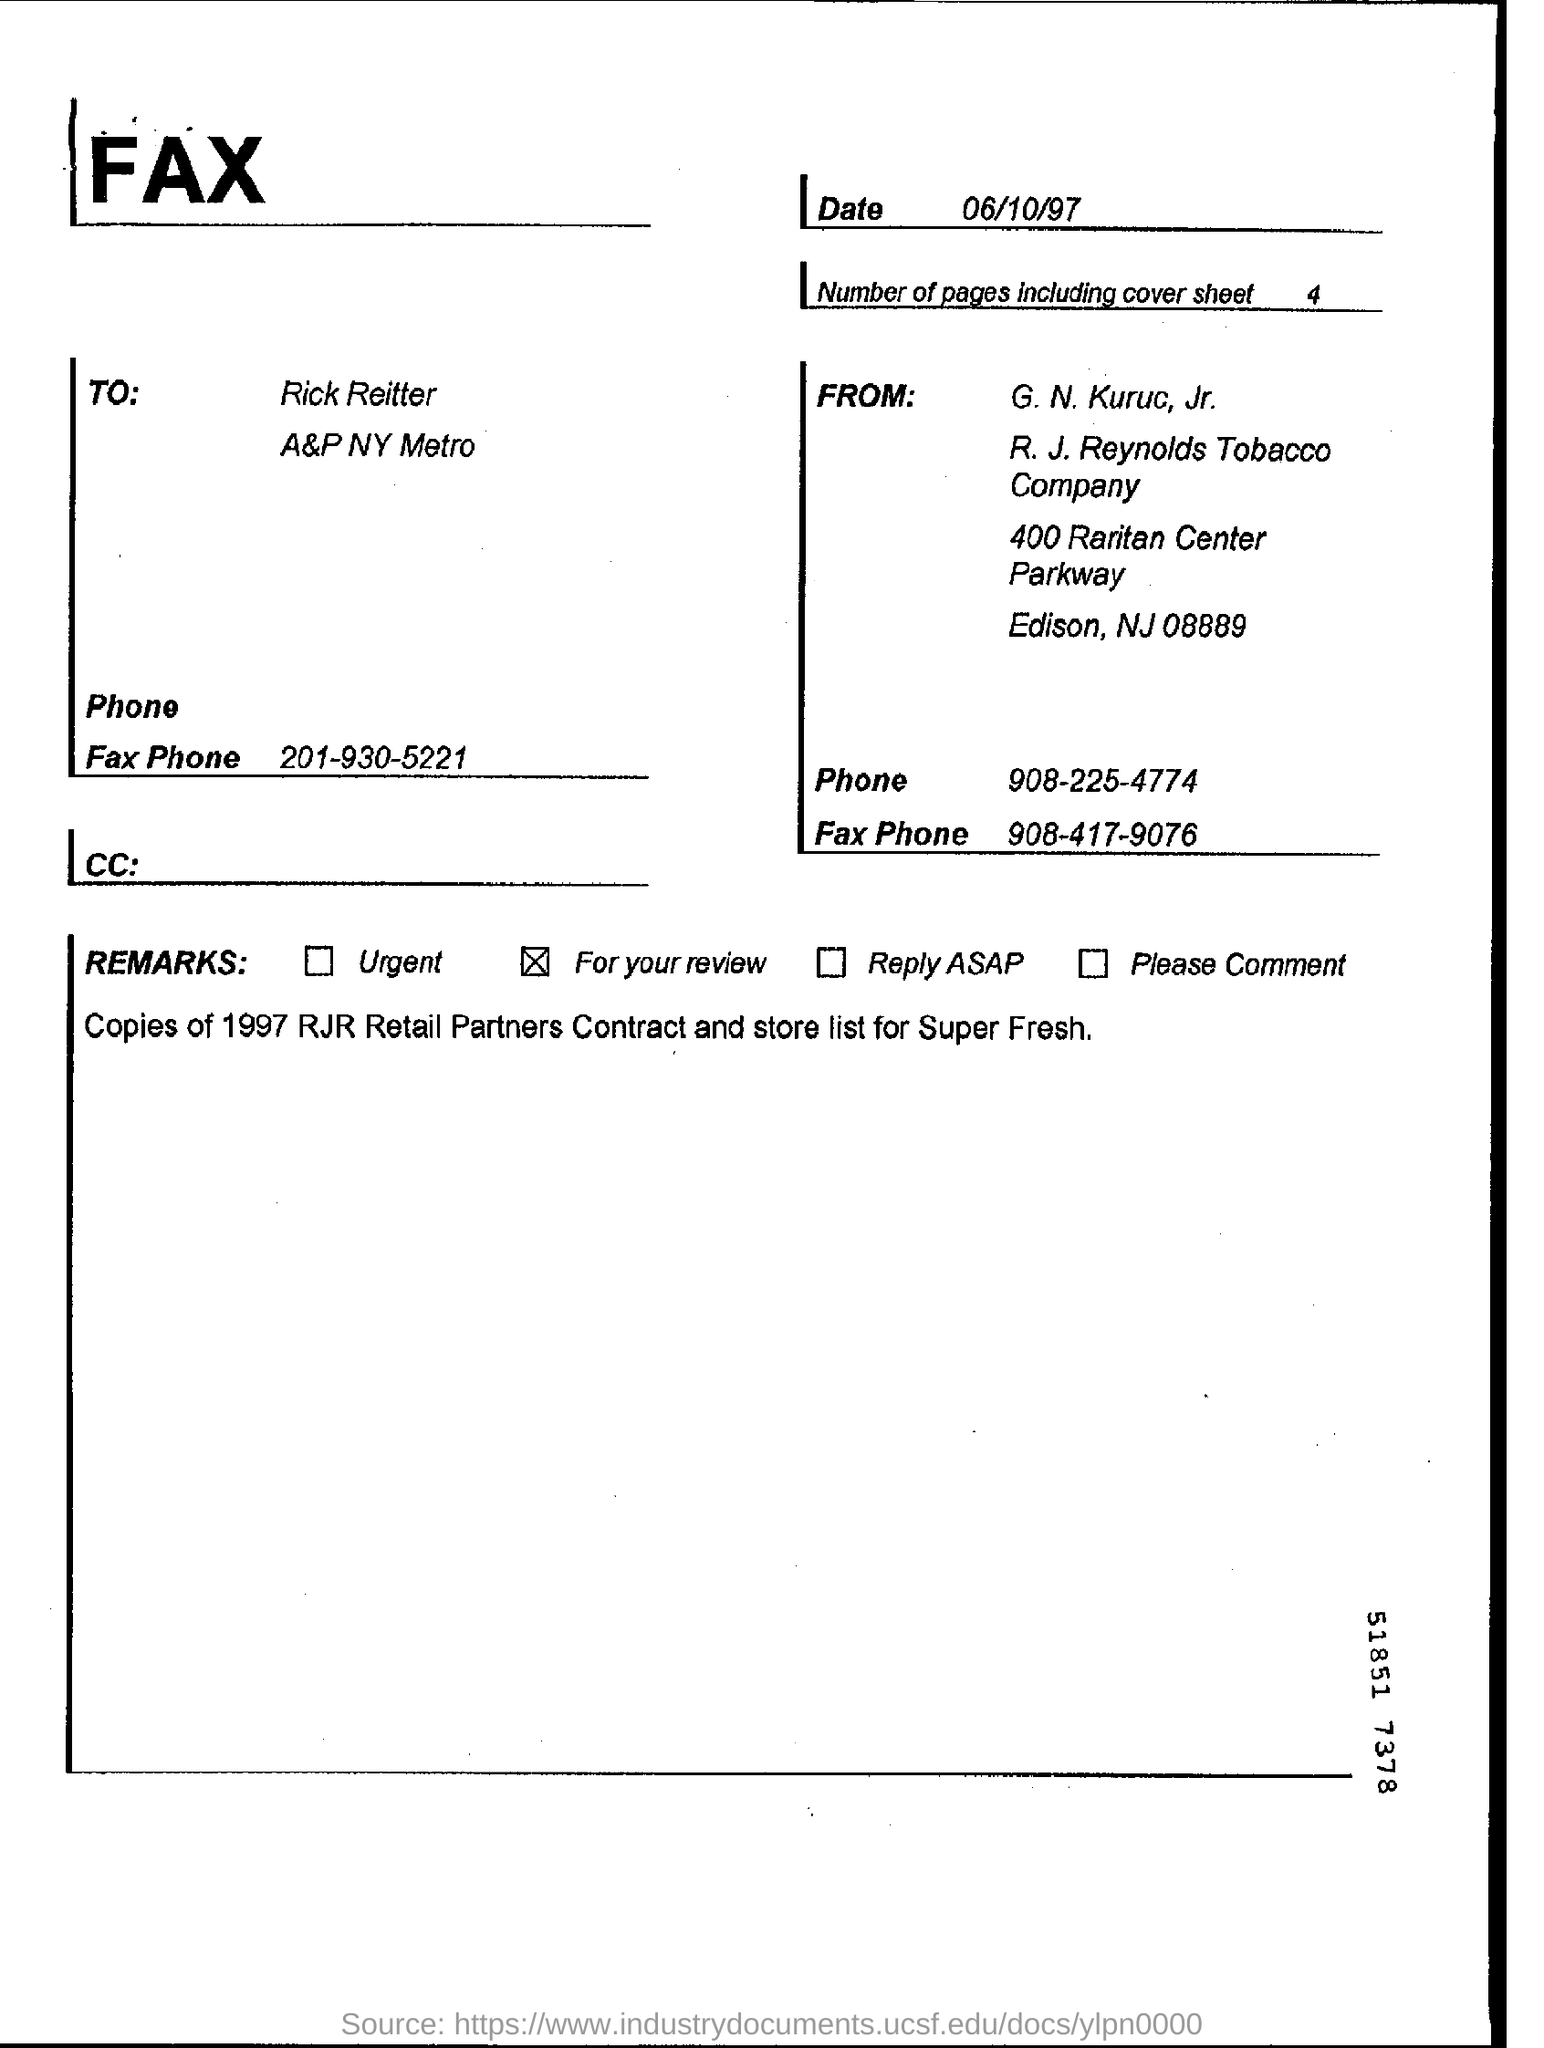List a handful of essential elements in this visual. The remark that was ticked for review is [insert description of remark]. The person who sent the fax is named G. N. Kuruc, Jr. On the date of June 10, 1997, the fax was sent. The fax was sent to Rick Reitter. 